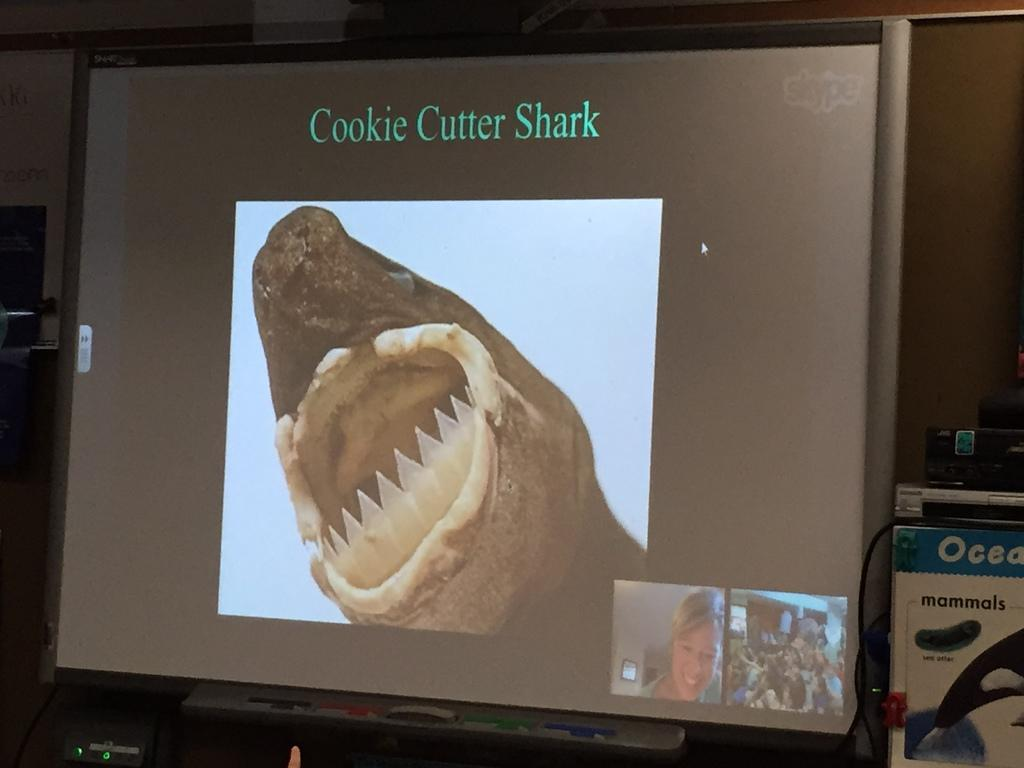Provide a one-sentence caption for the provided image. A computer monitor shows and image of a sharks mouth with plastic teeth beneath the words Cookie Cutter Shark. 